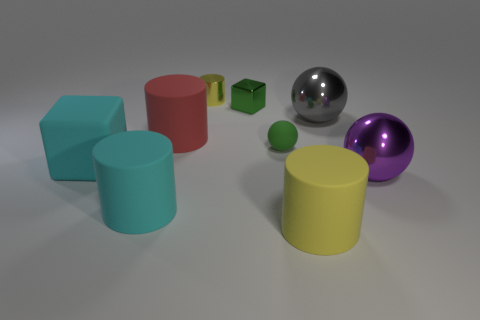Subtract all small yellow shiny cylinders. How many cylinders are left? 3 Subtract 2 cylinders. How many cylinders are left? 2 Subtract all cyan cubes. How many yellow cylinders are left? 2 Subtract all cyan cylinders. How many cylinders are left? 3 Add 1 large red objects. How many objects exist? 10 Subtract all blue cylinders. Subtract all blue balls. How many cylinders are left? 4 Subtract all blocks. How many objects are left? 7 Subtract 1 gray balls. How many objects are left? 8 Subtract all cyan rubber objects. Subtract all large green metal cubes. How many objects are left? 7 Add 3 tiny green metallic blocks. How many tiny green metallic blocks are left? 4 